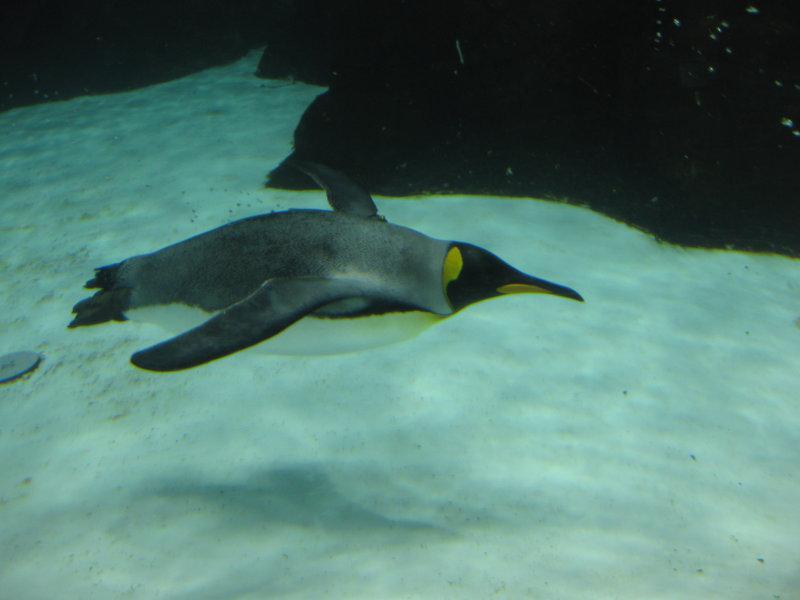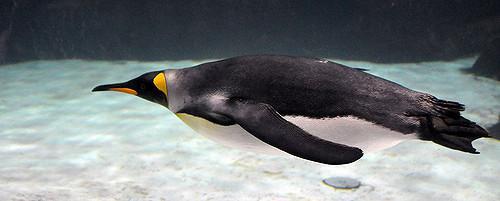The first image is the image on the left, the second image is the image on the right. Assess this claim about the two images: "There is no more than two penguins swimming underwater in the right image.". Correct or not? Answer yes or no. Yes. 